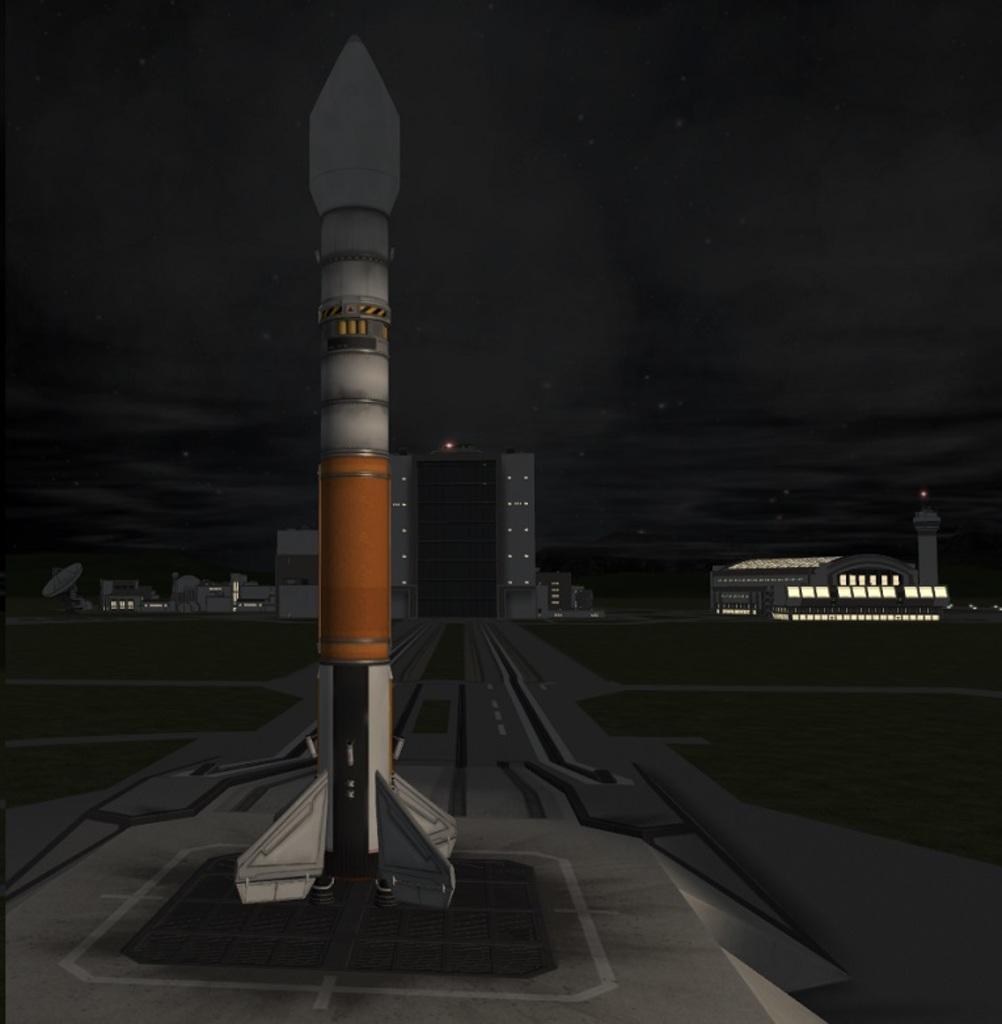Can you describe this image briefly? In this picture we can observe a missile. In the background there are buildings. We can observe sky here. 